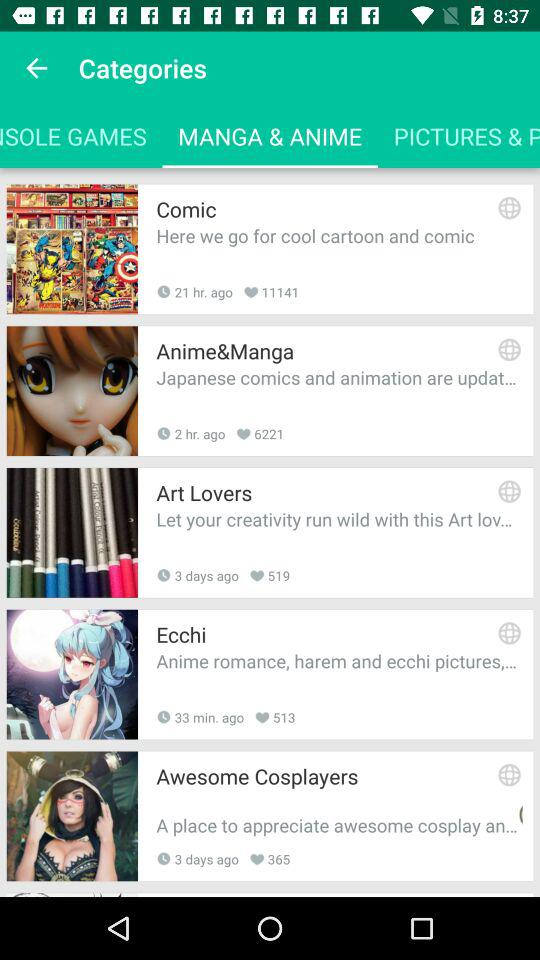Which option is selected in "Categories"? The selected option is "MANGA & ANIME". 